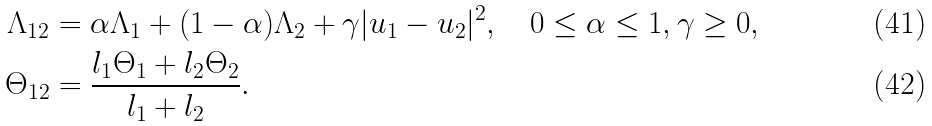<formula> <loc_0><loc_0><loc_500><loc_500>\Lambda _ { 1 2 } & = \alpha \Lambda _ { 1 } + ( 1 - \alpha ) \Lambda _ { 2 } + \gamma | u _ { 1 } - u _ { 2 } | ^ { 2 } , \quad 0 \leq \alpha \leq 1 , \gamma \geq 0 , \\ \Theta _ { 1 2 } & = \frac { l _ { 1 } \Theta _ { 1 } + l _ { 2 } \Theta _ { 2 } } { l _ { 1 } + l _ { 2 } } .</formula> 